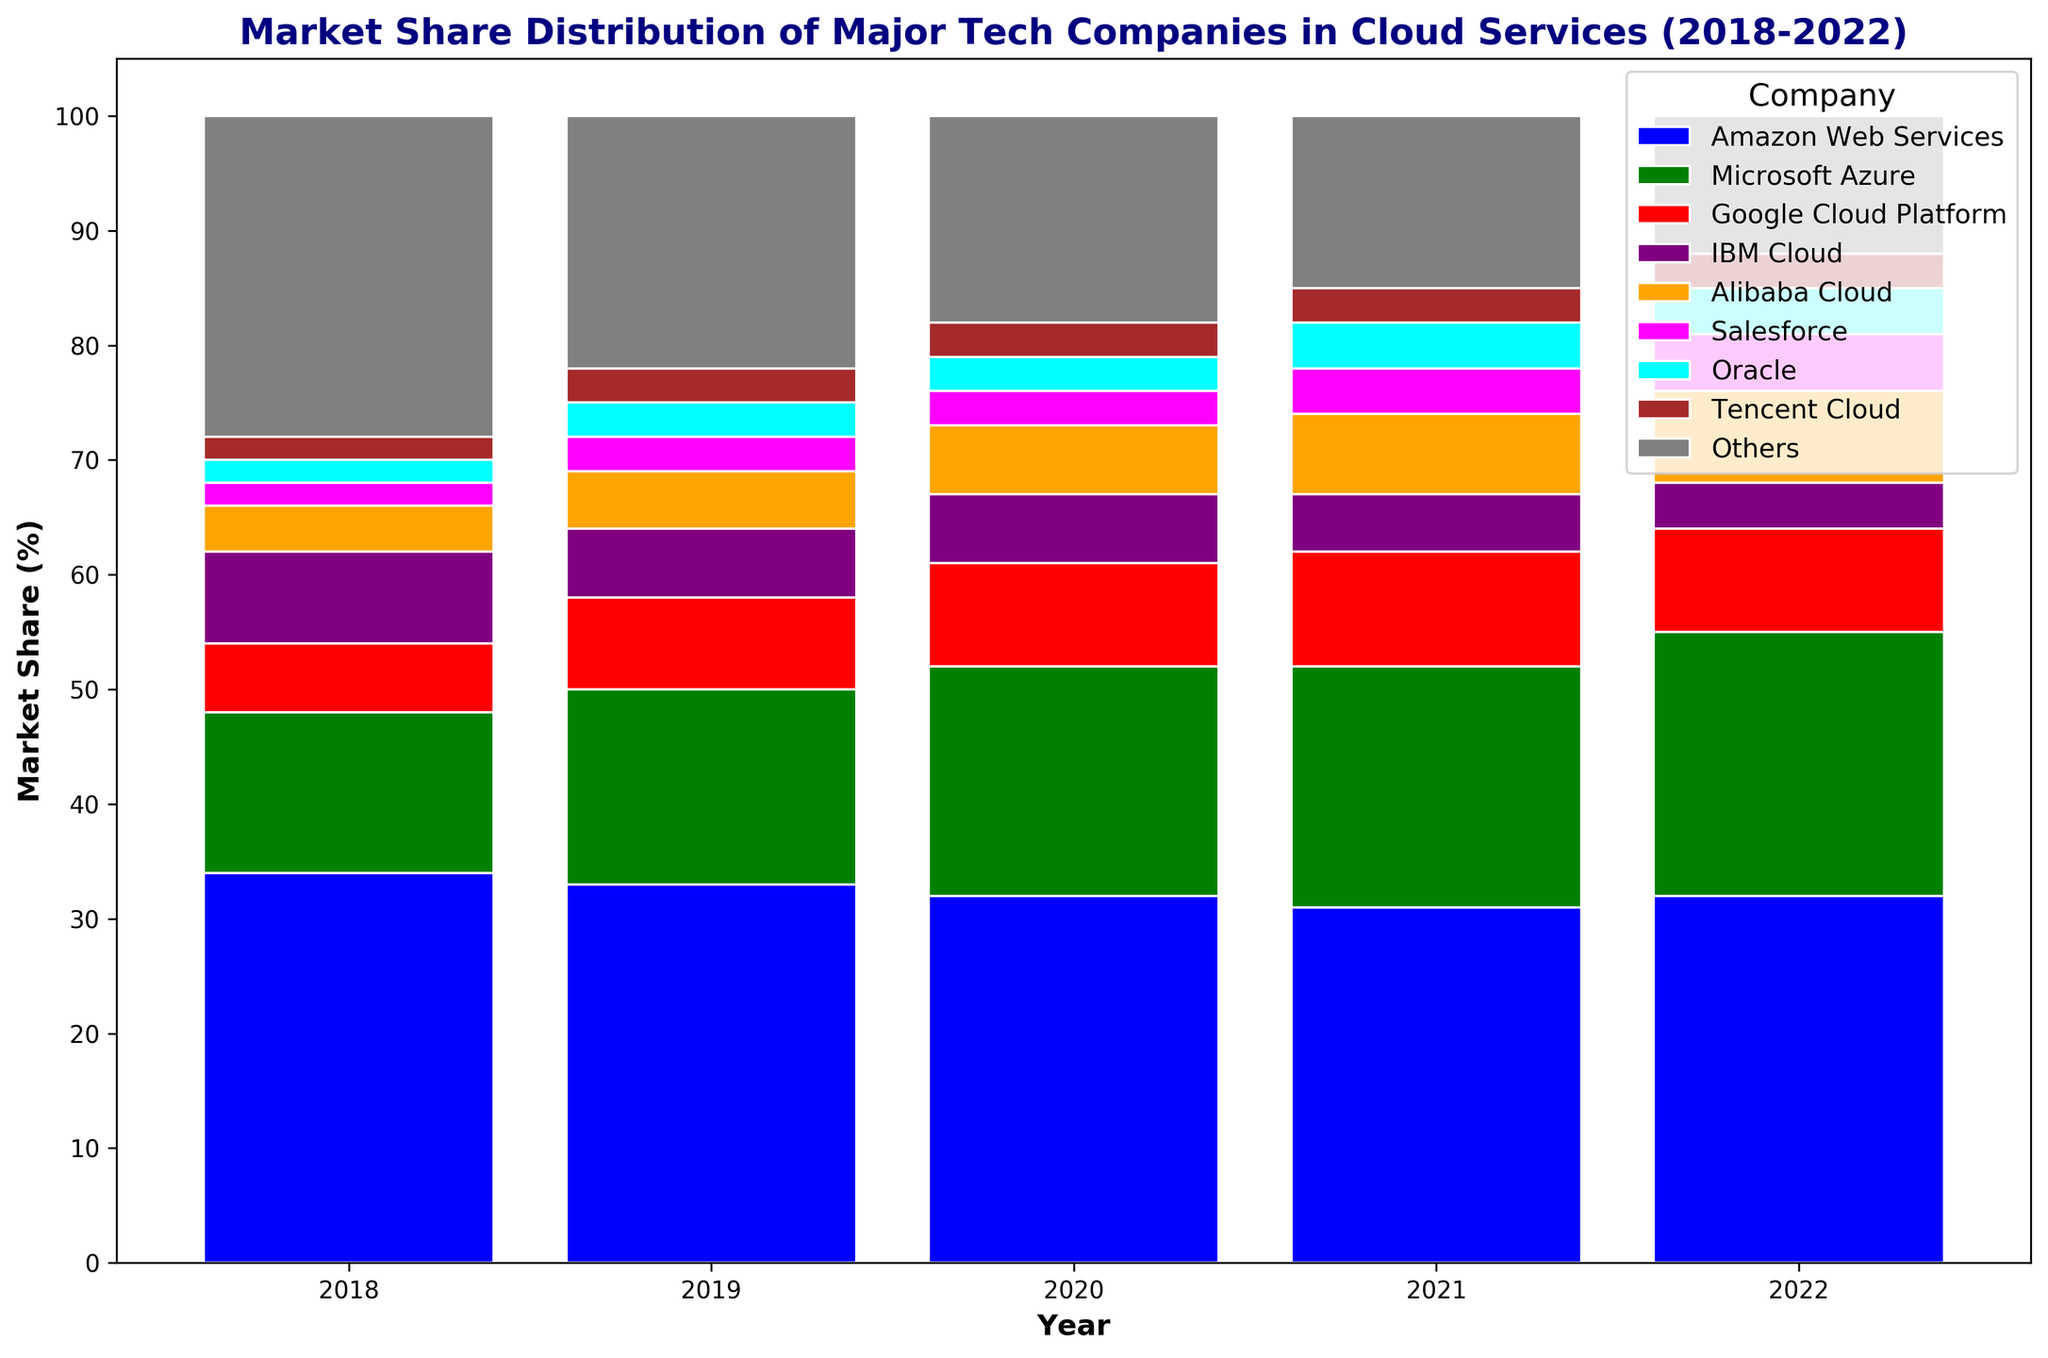Which company had the highest market share in 2022? Look at the height of the bars for each company in 2022. The tallest bar represents the company with the highest market share.
Answer: Amazon Web Services How did Microsoft Azure's market share change from 2018 to 2022? Compare the heights of the bars representing Microsoft Azure in 2018 and 2022 to see the increase or decrease. In 2018, Microsoft Azure had a market share of 14%, and in 2022, it had a market share of 23%.
Answer: Increased by 9% Which company had the smallest change in market share over the five years? Check each company's bar heights across the years from 2018 to 2022 and identify the one with the smallest difference between its highest and lowest values.
Answer: Tencent Cloud By how much did Google's market share increase from 2018 to 2021? Look at the height of the bars for Google Cloud Platform in 2018 and 2021 and calculate the difference. In 2018, Google's market share was 6%, and in 2021, it was 10%. Subtract 6% from 10% for the increase.
Answer: 4% What was the combined market share of Microsoft Azure and Google Cloud Platform in 2019? Add the heights of the bars representing Microsoft Azure and Google Cloud Platform in 2019. Microsoft Azure had 17%, and Google Cloud Platform had 8%.
Answer: 25% Which year saw the highest market share for Microsoft Azure? Look at the bars for Microsoft Azure across all five years and identify the tallest one.
Answer: 2022 Did IBM Cloud's market share increase or decrease from 2020 to 2022? Compare the bar heights for IBM Cloud between 2020 and 2022. It had a market share of 6% in 2020 and 4% in 2022.
Answer: Decreased Which two companies had equal market shares in 2018? Look at the heights of the bars for each company in 2018 and identify any two companies with bars of the same height. Both Salesforce and Oracle had a market share of 2%.
Answer: Salesforce and Oracle What percentage of the market did the 'Others' category represent in 2022? Find the bar representing 'Others' in 2022 and read the value at the top of the bar.
Answer: 12% How did the market share of Alibaba Cloud change from 2019 to 2021? Compare the bar heights for Alibaba Cloud in 2019 and 2021. In 2019, it had a 5% market share, and in 2021, it had 7%.
Answer: Increased by 2% 